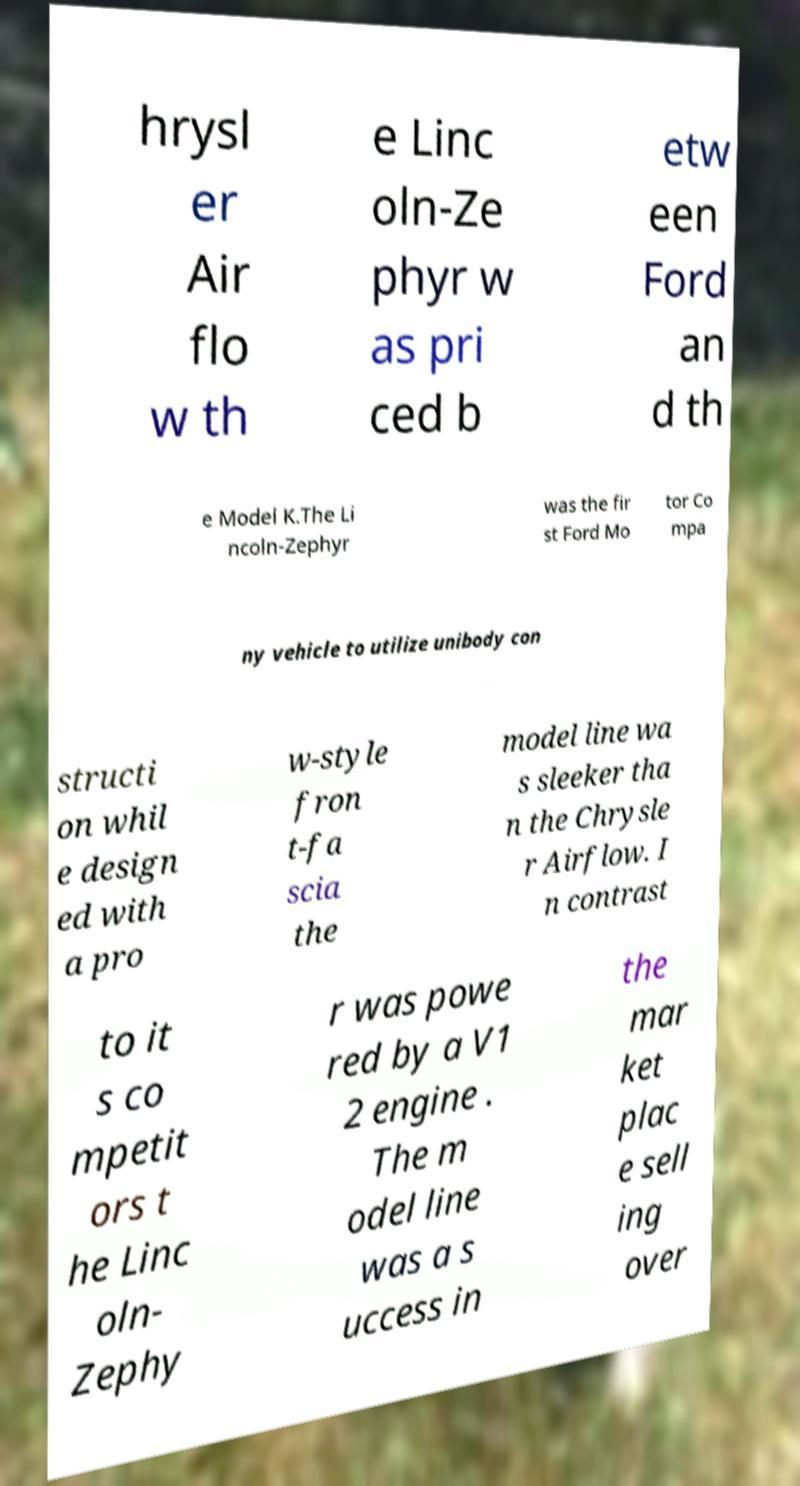Can you accurately transcribe the text from the provided image for me? hrysl er Air flo w th e Linc oln-Ze phyr w as pri ced b etw een Ford an d th e Model K.The Li ncoln-Zephyr was the fir st Ford Mo tor Co mpa ny vehicle to utilize unibody con structi on whil e design ed with a pro w-style fron t-fa scia the model line wa s sleeker tha n the Chrysle r Airflow. I n contrast to it s co mpetit ors t he Linc oln- Zephy r was powe red by a V1 2 engine . The m odel line was a s uccess in the mar ket plac e sell ing over 